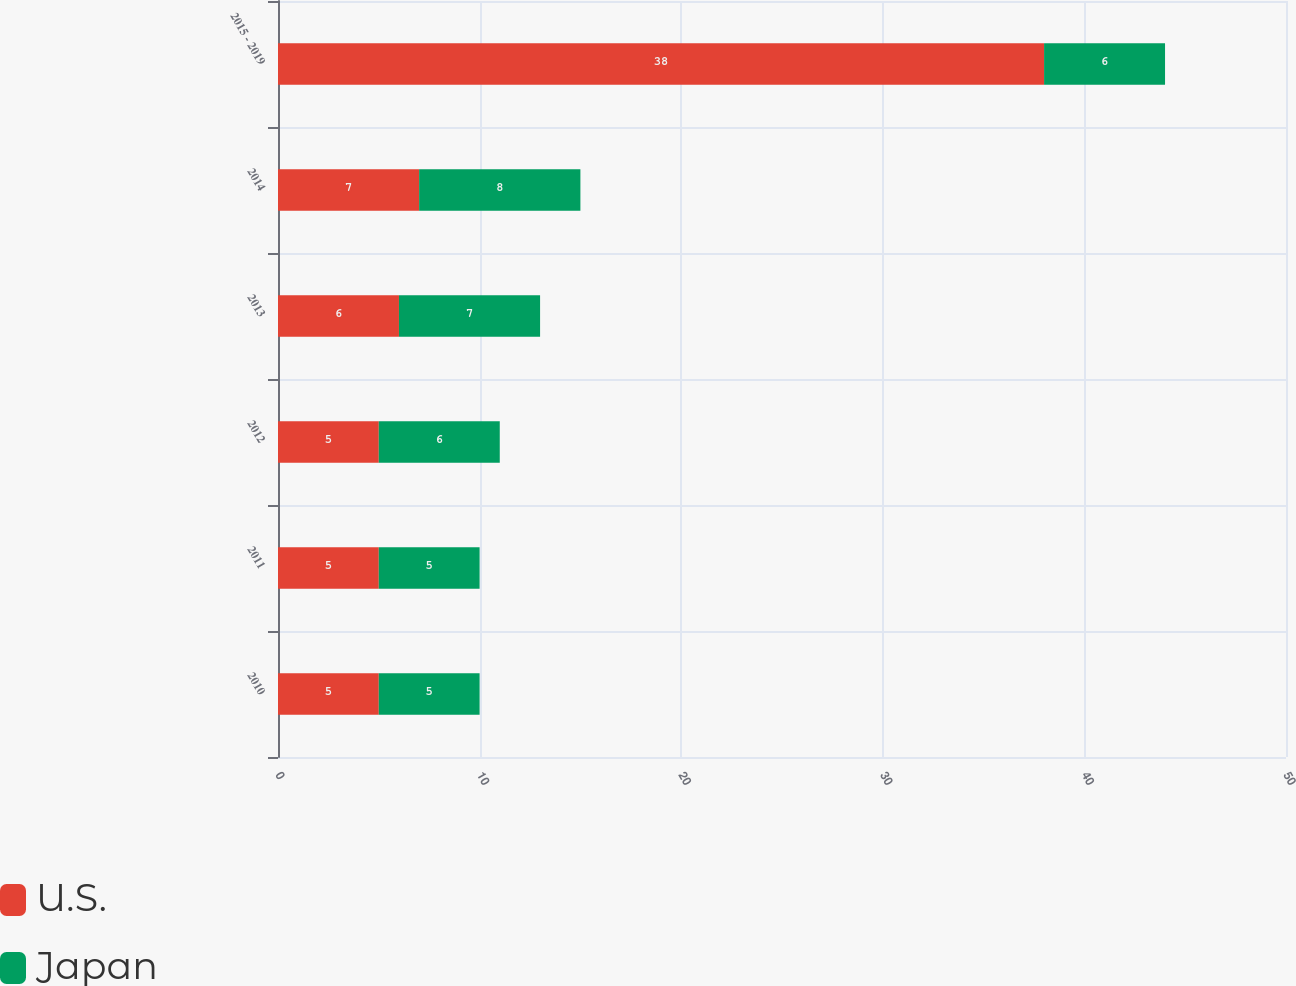Convert chart. <chart><loc_0><loc_0><loc_500><loc_500><stacked_bar_chart><ecel><fcel>2010<fcel>2011<fcel>2012<fcel>2013<fcel>2014<fcel>2015 - 2019<nl><fcel>U.S.<fcel>5<fcel>5<fcel>5<fcel>6<fcel>7<fcel>38<nl><fcel>Japan<fcel>5<fcel>5<fcel>6<fcel>7<fcel>8<fcel>6<nl></chart> 